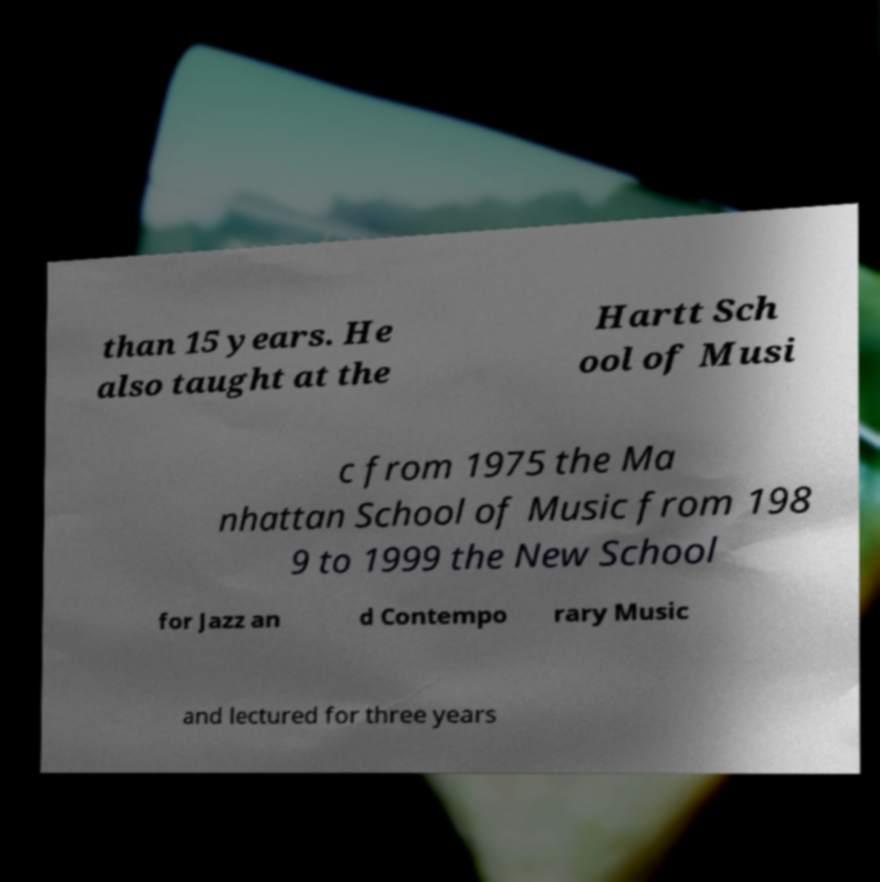What messages or text are displayed in this image? I need them in a readable, typed format. than 15 years. He also taught at the Hartt Sch ool of Musi c from 1975 the Ma nhattan School of Music from 198 9 to 1999 the New School for Jazz an d Contempo rary Music and lectured for three years 